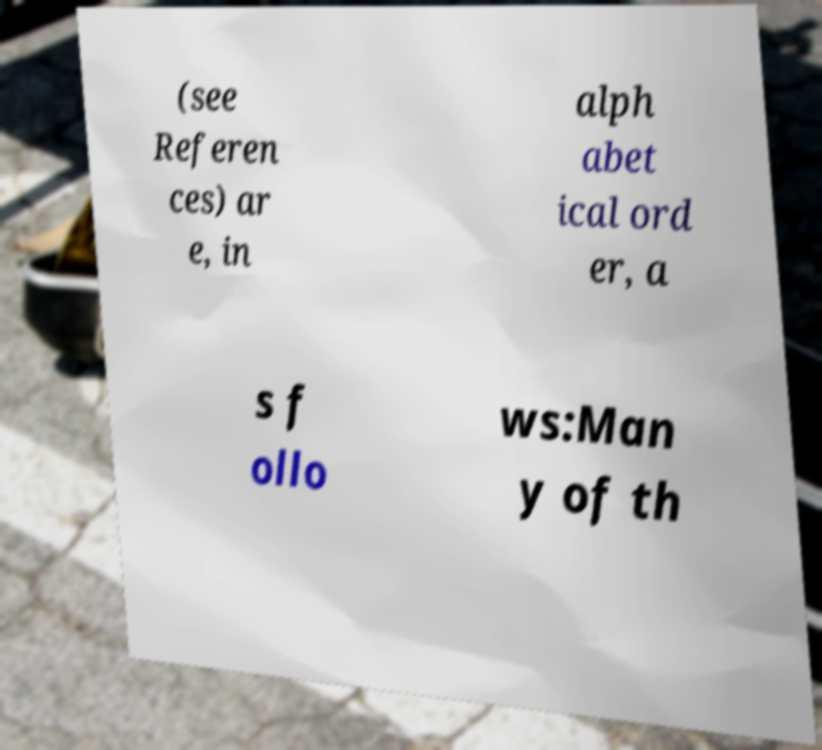Could you assist in decoding the text presented in this image and type it out clearly? (see Referen ces) ar e, in alph abet ical ord er, a s f ollo ws:Man y of th 